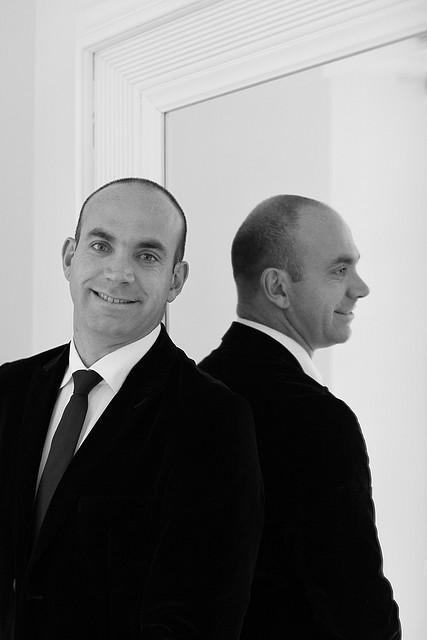How many mirrors are there?
Give a very brief answer. 1. How many people are there?
Give a very brief answer. 2. 